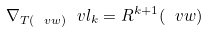Convert formula to latex. <formula><loc_0><loc_0><loc_500><loc_500>\nabla _ { T ( \ v w ) } \ v l _ { k } = R ^ { k + 1 } ( \ v w )</formula> 